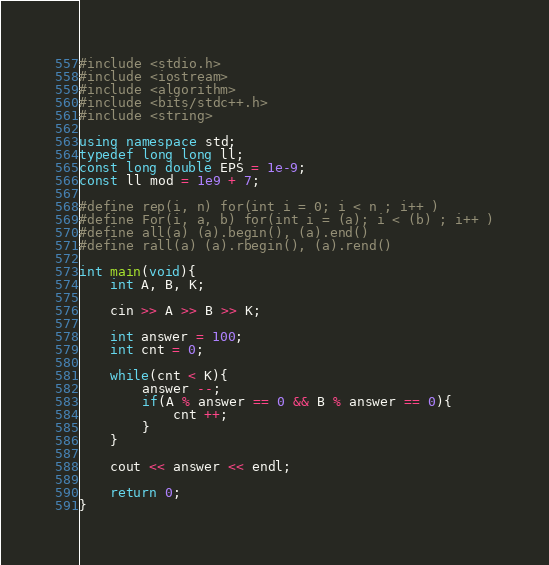<code> <loc_0><loc_0><loc_500><loc_500><_C++_>#include <stdio.h>
#include <iostream>
#include <algorithm>
#include <bits/stdc++.h>
#include <string>

using namespace std;
typedef long long ll;
const long double EPS = 1e-9;
const ll mod = 1e9 + 7;

#define rep(i, n) for(int i = 0; i < n ; i++ )
#define For(i, a, b) for(int i = (a); i < (b) ; i++ )
#define all(a) (a).begin(), (a).end()
#define rall(a) (a).rbegin(), (a).rend()

int main(void){
    int A, B, K;
    
    cin >> A >> B >> K;
    
    int answer = 100;
    int cnt = 0;

    while(cnt < K){
        answer --;
        if(A % answer == 0 && B % answer == 0){
            cnt ++;
        }
    }

    cout << answer << endl;

    return 0;
}</code> 